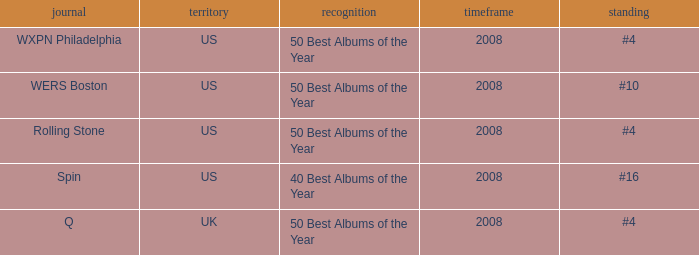Which publication happened in the UK? Q. 